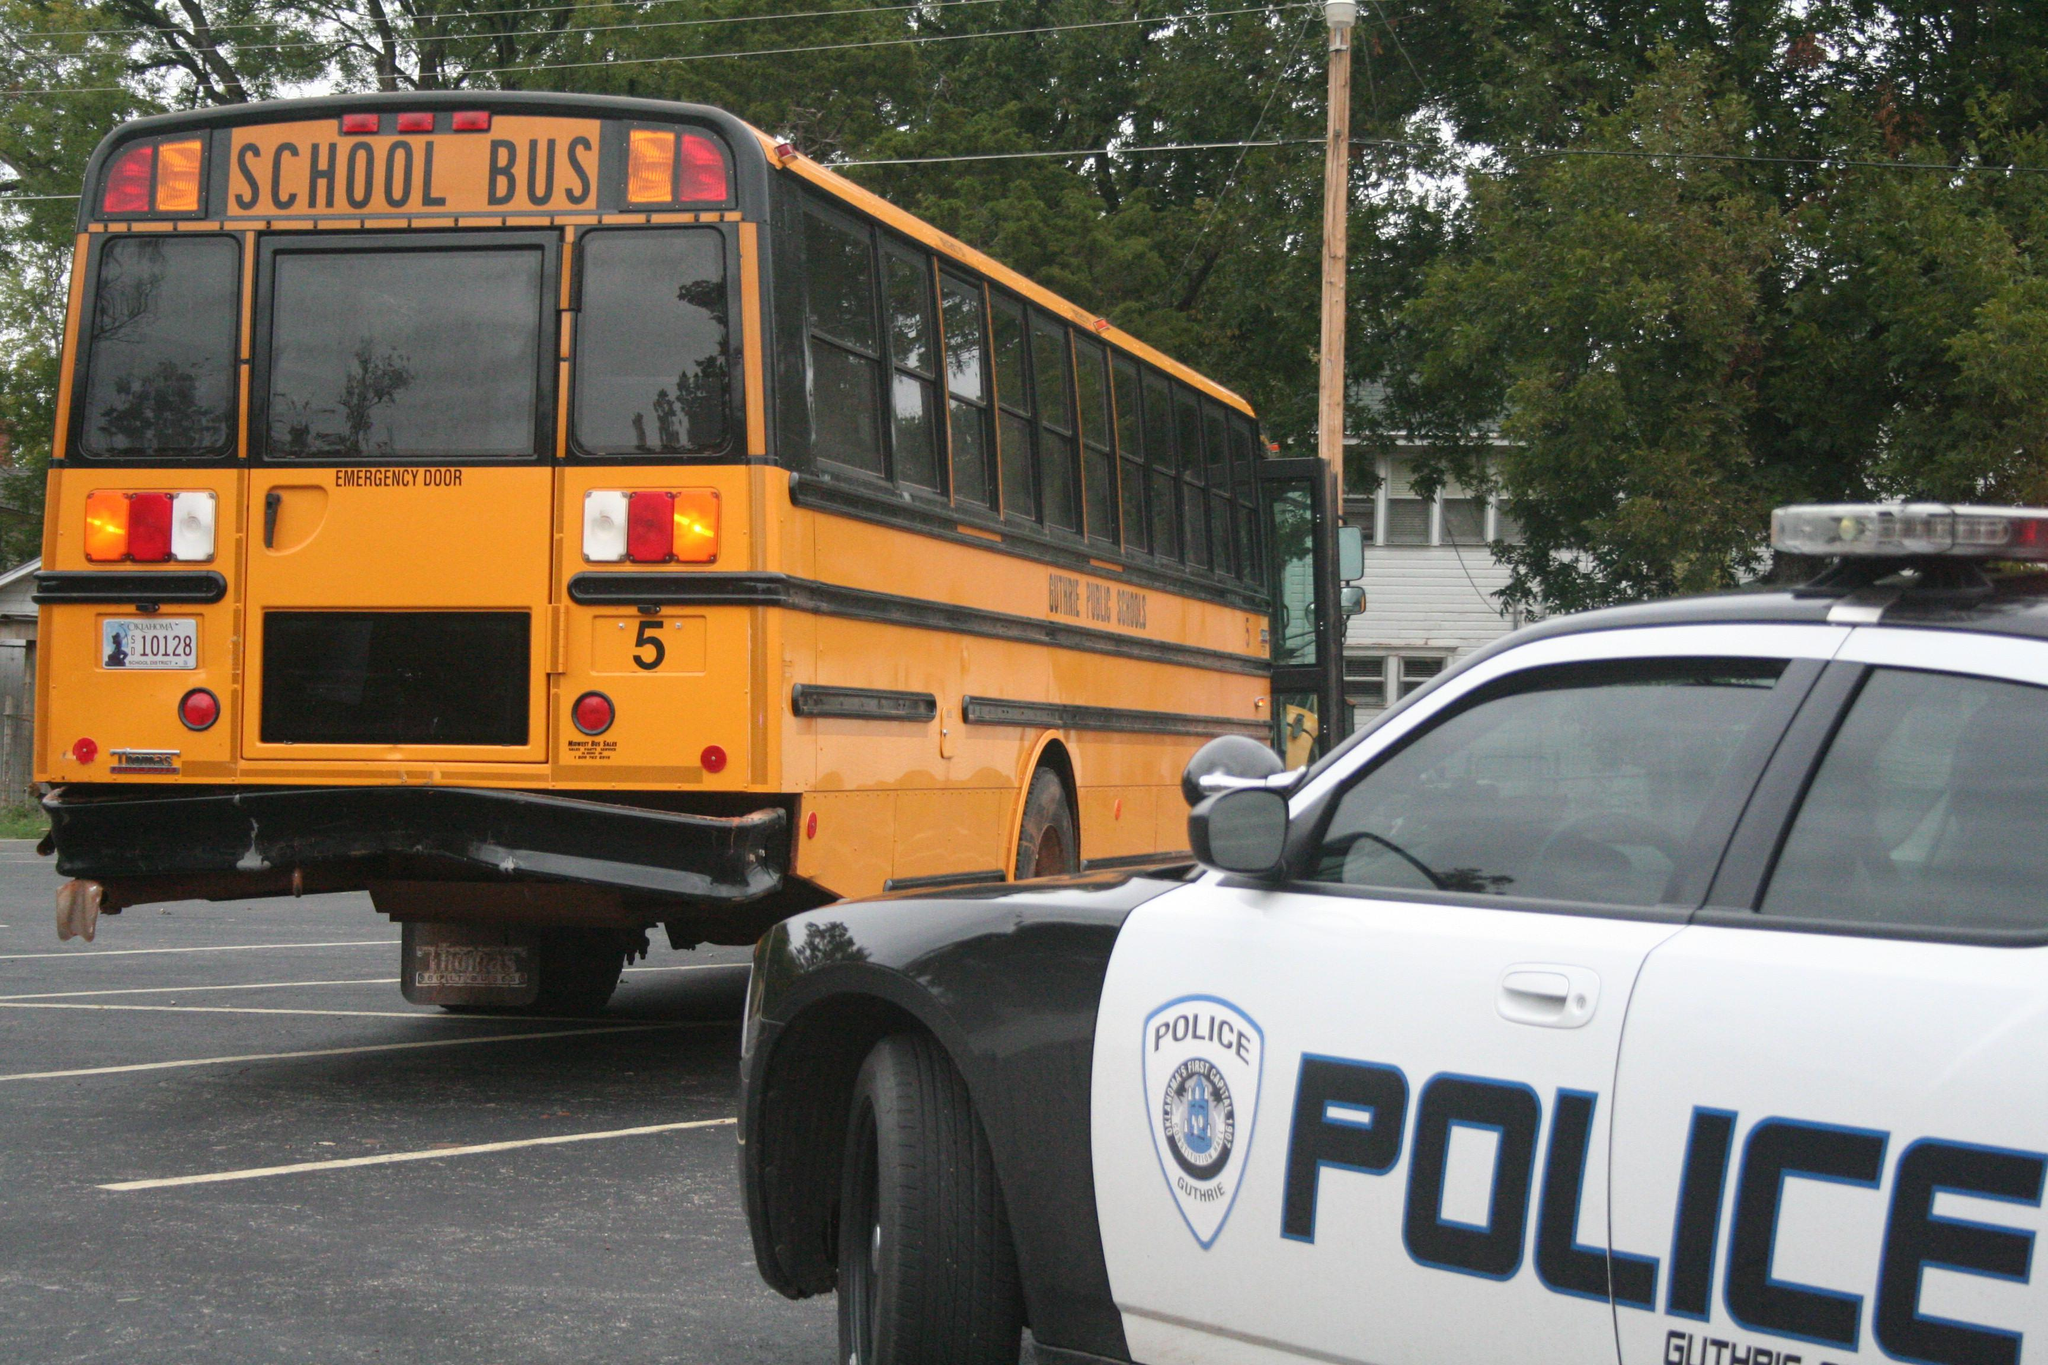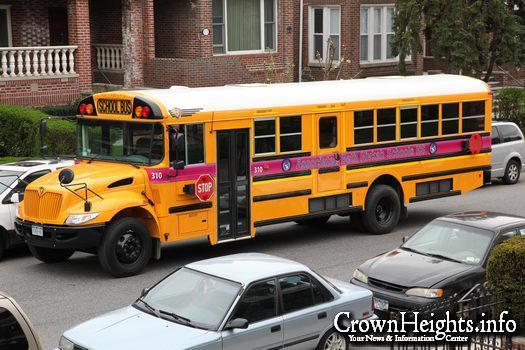The first image is the image on the left, the second image is the image on the right. For the images displayed, is the sentence "There are one or more people next to the school bus in one image, but not the other." factually correct? Answer yes or no. No. The first image is the image on the left, the second image is the image on the right. For the images displayed, is the sentence "People are standing outside near a bus in the image on the left." factually correct? Answer yes or no. No. 